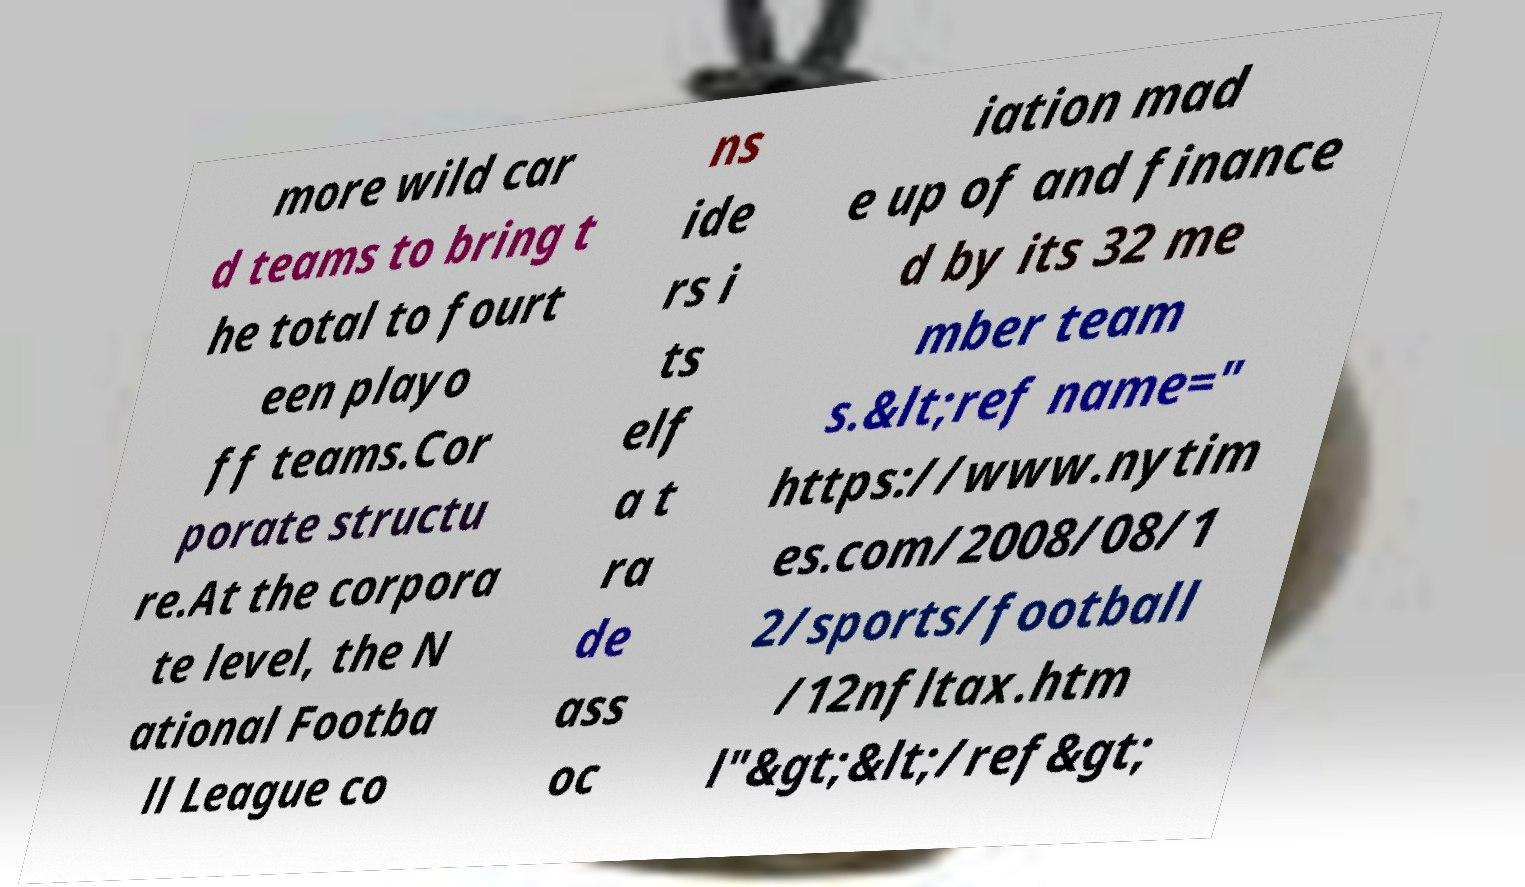Could you assist in decoding the text presented in this image and type it out clearly? more wild car d teams to bring t he total to fourt een playo ff teams.Cor porate structu re.At the corpora te level, the N ational Footba ll League co ns ide rs i ts elf a t ra de ass oc iation mad e up of and finance d by its 32 me mber team s.&lt;ref name=" https://www.nytim es.com/2008/08/1 2/sports/football /12nfltax.htm l"&gt;&lt;/ref&gt; 